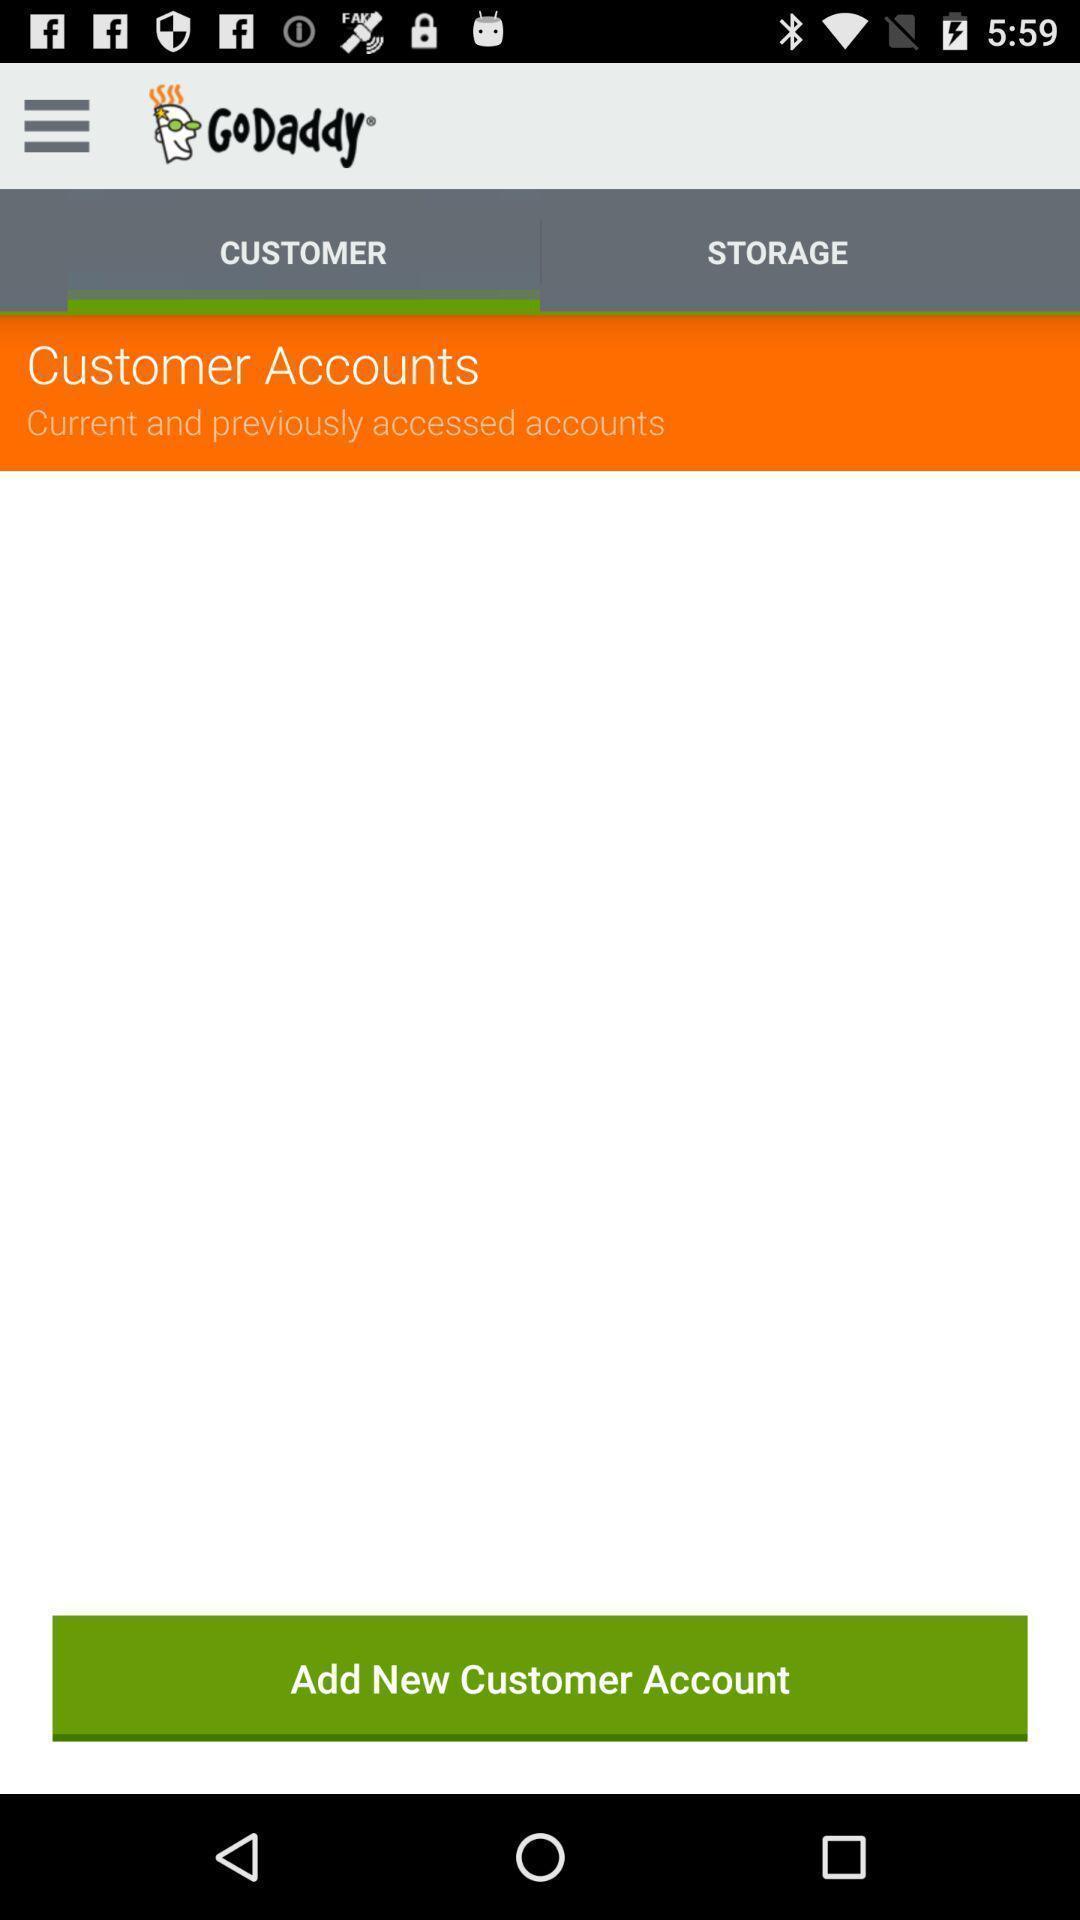What can you discern from this picture? Screen display customer accounts page of a trading app. 